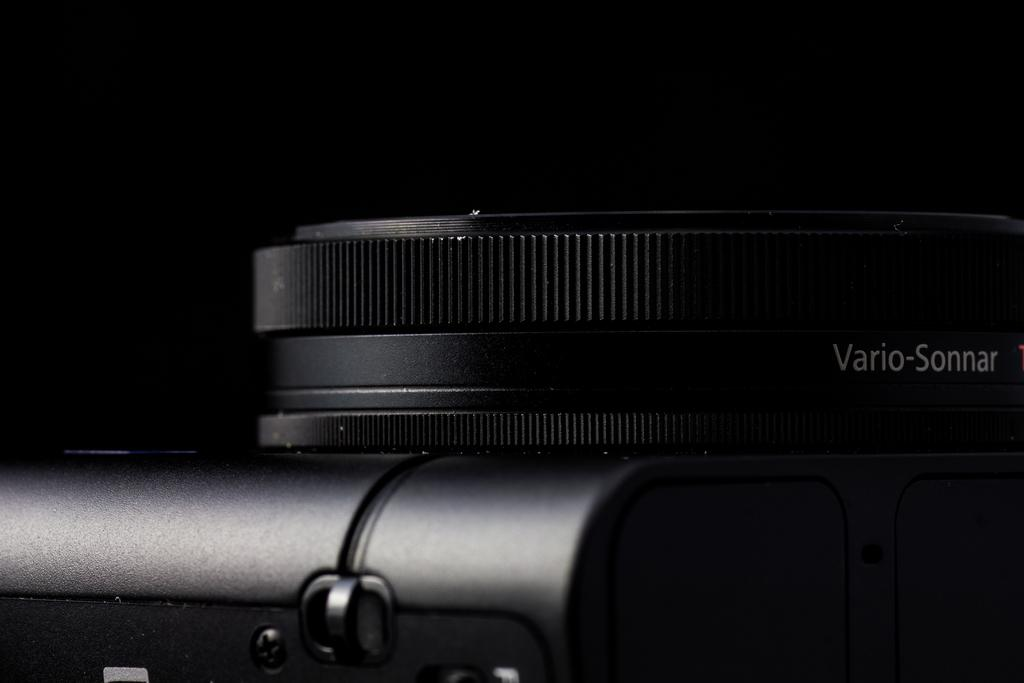What is the main subject of the zoom-in picture? The main subject of the zoom-in picture is a camera. Can you describe the type of picture this is? This is a zoom-in picture, which means it is a close-up view of the subject. Where is the father in the image? There is no father present in the image; it features a camera. What type of animal can be seen flying in the image? There are no animals, including bats, present in the image. 